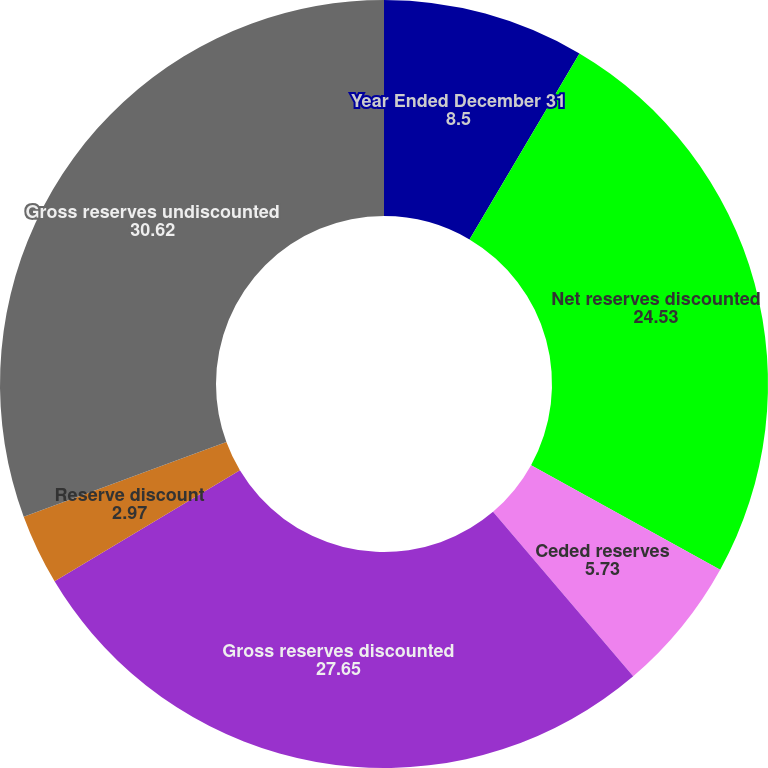<chart> <loc_0><loc_0><loc_500><loc_500><pie_chart><fcel>Year Ended December 31<fcel>Net reserves discounted<fcel>Ceded reserves<fcel>Gross reserves discounted<fcel>Reserve discount<fcel>Gross reserves undiscounted<nl><fcel>8.5%<fcel>24.53%<fcel>5.73%<fcel>27.65%<fcel>2.97%<fcel>30.62%<nl></chart> 